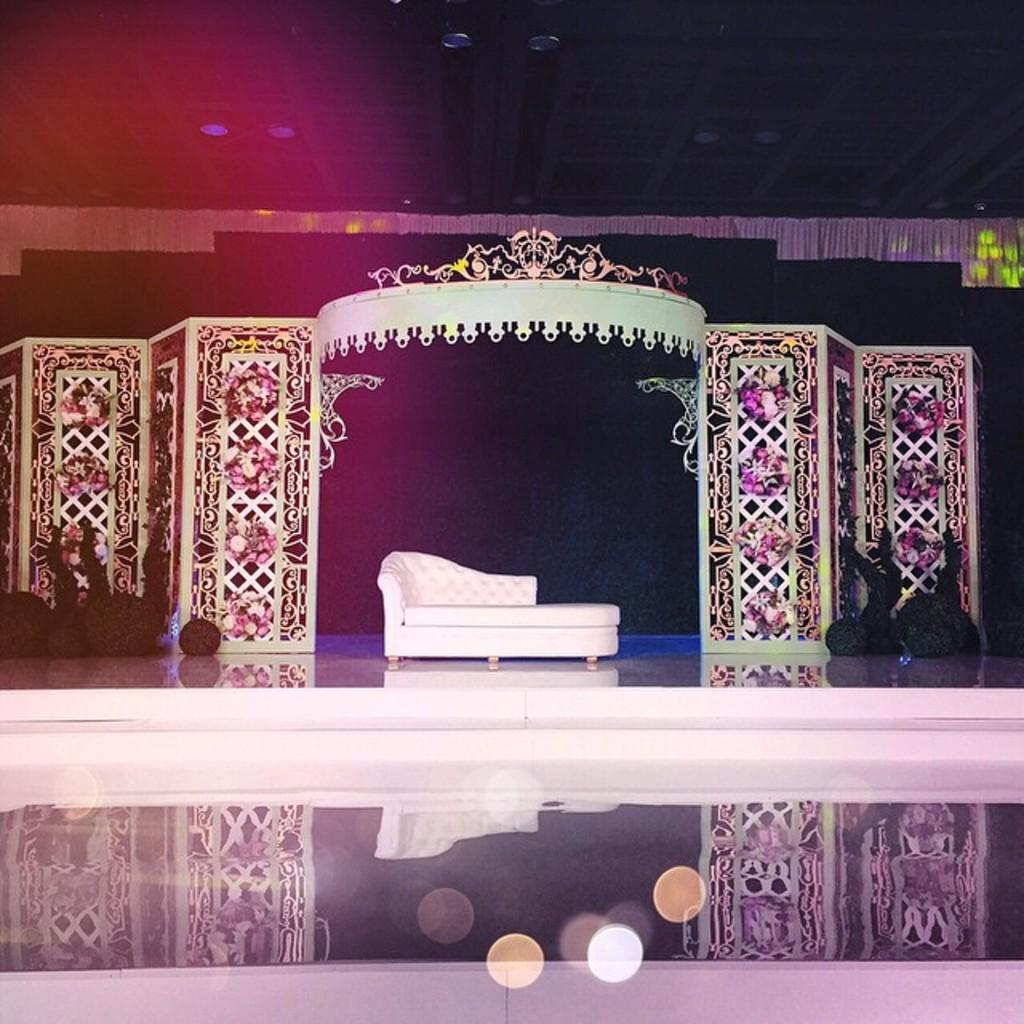Where was the image taken? The image was taken in a function hall. What can be seen on the stage in the image? There is a white color sofa on the stage. How is the stage decorated in the image? The background of the stage is decorated with items. Can you see any snails crawling on the white sofa in the image? No, there are no snails present in the image. What type of board is used for the decoration on the stage? There is no board mentioned or visible in the image for decoration purposes. 